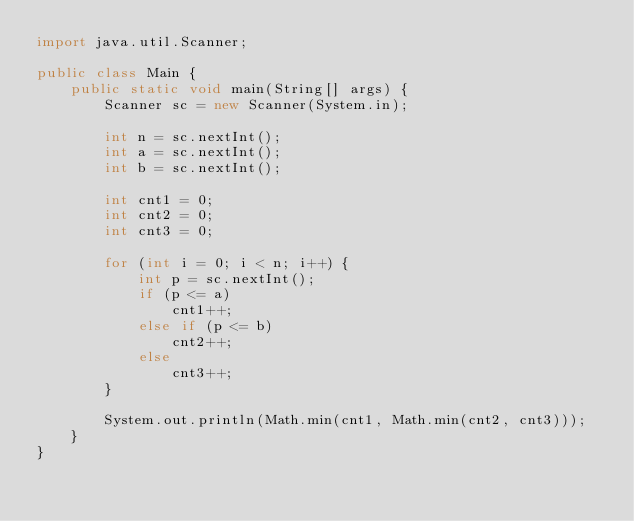<code> <loc_0><loc_0><loc_500><loc_500><_Java_>import java.util.Scanner;

public class Main {
    public static void main(String[] args) {
        Scanner sc = new Scanner(System.in);

        int n = sc.nextInt();
        int a = sc.nextInt();
        int b = sc.nextInt();
        
        int cnt1 = 0;
        int cnt2 = 0;
        int cnt3 = 0;
        
        for (int i = 0; i < n; i++) {
            int p = sc.nextInt();
            if (p <= a)
                cnt1++;
            else if (p <= b)
                cnt2++;
            else
                cnt3++;
        }
        
        System.out.println(Math.min(cnt1, Math.min(cnt2, cnt3)));
    }
}

</code> 